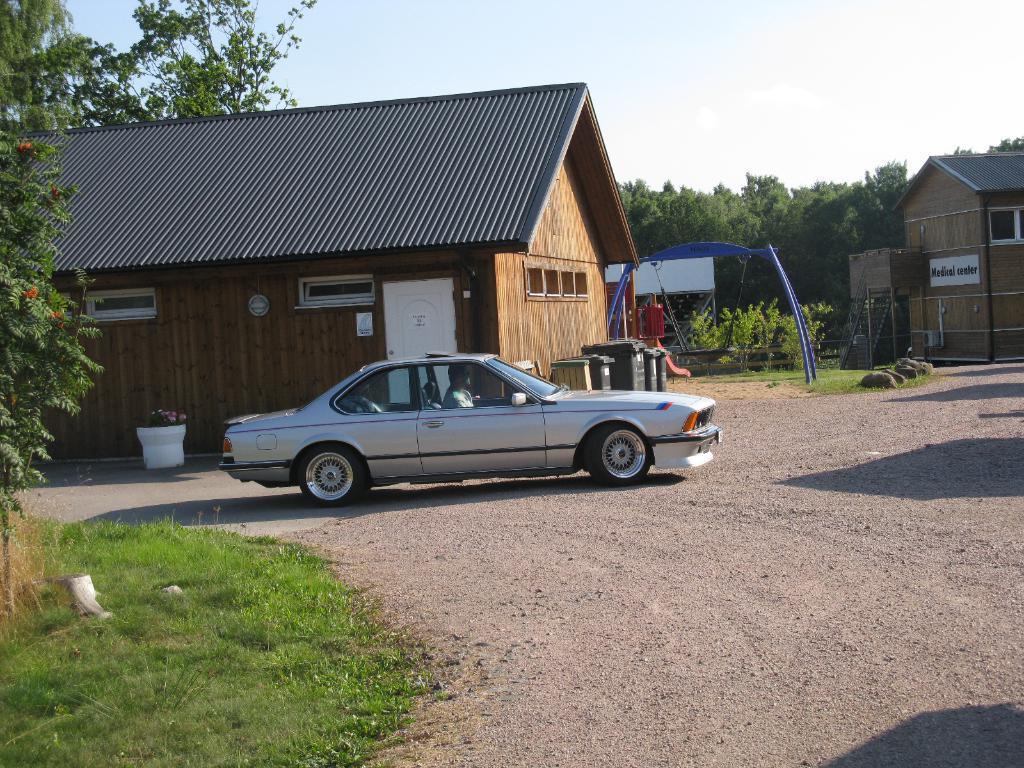Can you describe this image briefly? In this image there is a car moving on a road. To the left there are plants and grass on the ground. Behind the car there are houses. Beside the house there are are barrels and containers. In front of the house there is a flower pot. In the background there are trees and a swing. At the top there is the sky. 